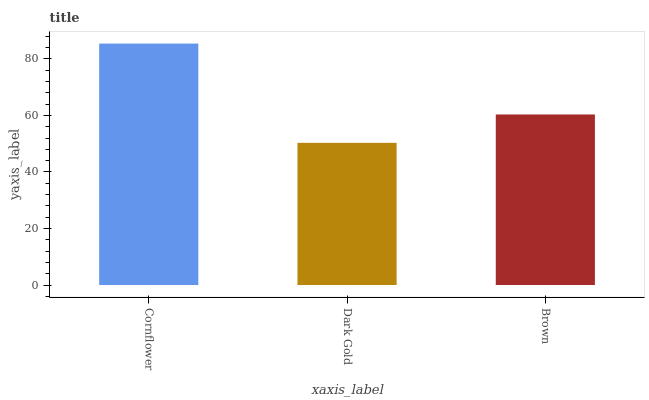Is Dark Gold the minimum?
Answer yes or no. Yes. Is Cornflower the maximum?
Answer yes or no. Yes. Is Brown the minimum?
Answer yes or no. No. Is Brown the maximum?
Answer yes or no. No. Is Brown greater than Dark Gold?
Answer yes or no. Yes. Is Dark Gold less than Brown?
Answer yes or no. Yes. Is Dark Gold greater than Brown?
Answer yes or no. No. Is Brown less than Dark Gold?
Answer yes or no. No. Is Brown the high median?
Answer yes or no. Yes. Is Brown the low median?
Answer yes or no. Yes. Is Dark Gold the high median?
Answer yes or no. No. Is Cornflower the low median?
Answer yes or no. No. 